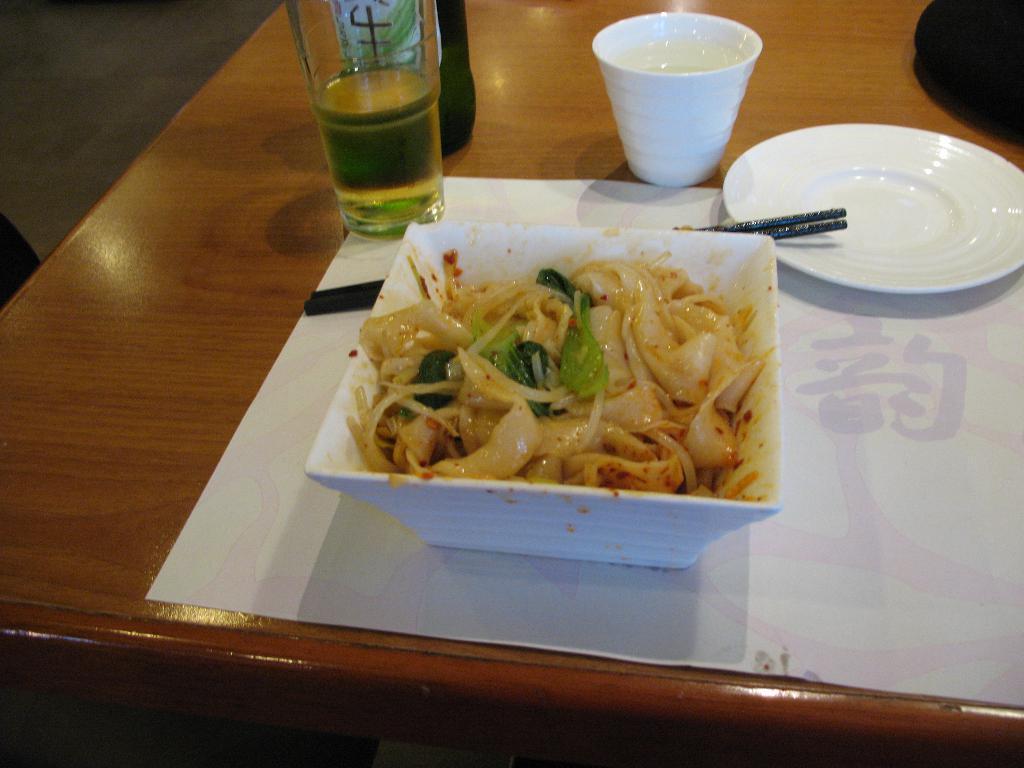Describe this image in one or two sentences. In this picture we can observe some food in the white color bowl. The bowl is on the brown color table. We can observe a white color table mat. There are two black color chopsticks and a plate which is in white color. We can observe two glasses on this brown color table. 